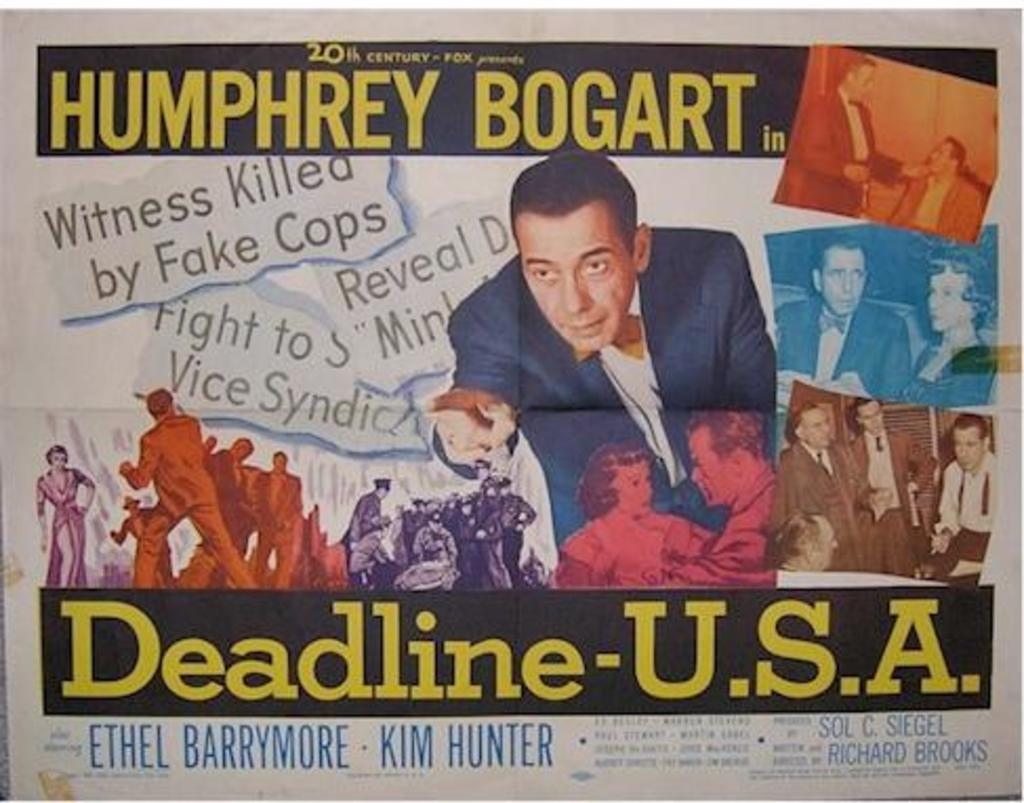<image>
Give a short and clear explanation of the subsequent image. A movie poster for "Deadline-U.S.A." starring Humphrey Bogart. 